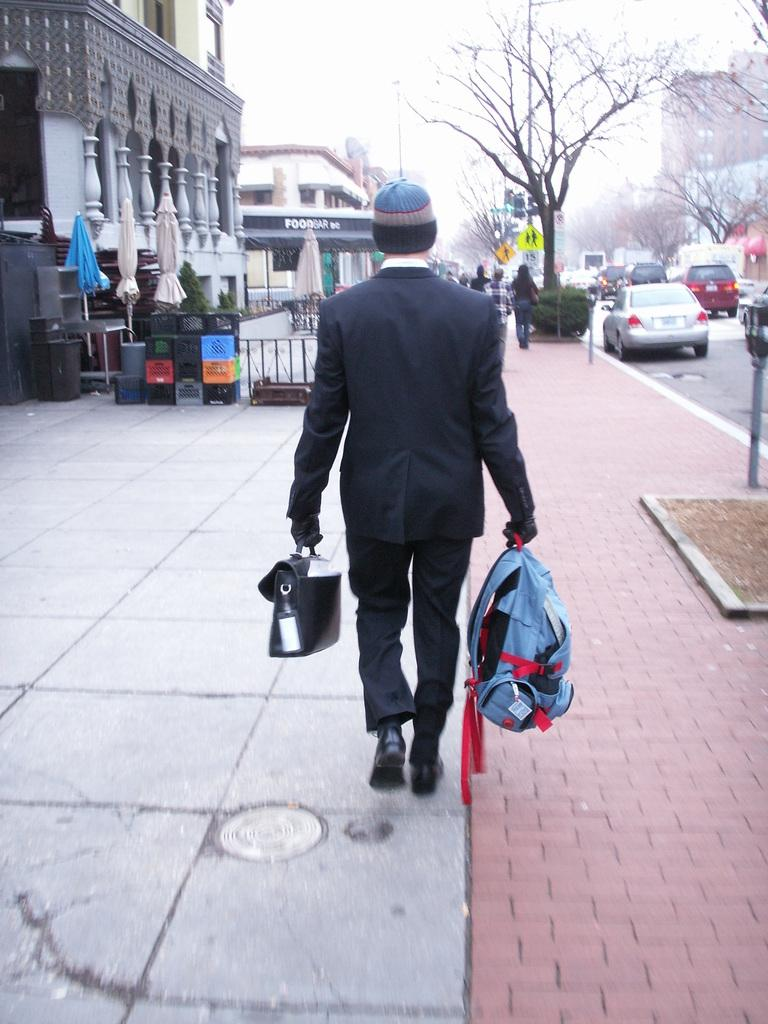What is the man in the image doing? The man in the image is walking on the road. What is the man carrying while walking? The man is carrying bags in his hands. What can be seen in the background of the image? There are cars, buildings, and trees visible in the image. What type of grain is being harvested in the image? There is no grain visible in the image; it features a man walking on the road and carrying bags. 